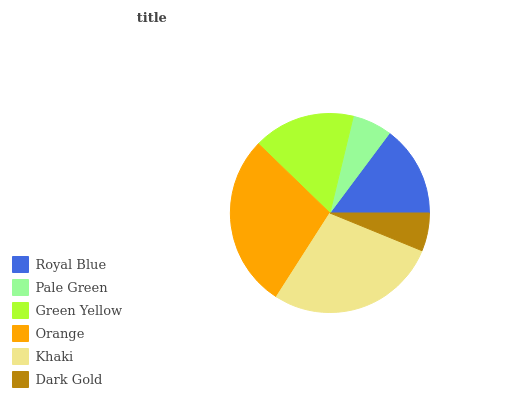Is Dark Gold the minimum?
Answer yes or no. Yes. Is Orange the maximum?
Answer yes or no. Yes. Is Pale Green the minimum?
Answer yes or no. No. Is Pale Green the maximum?
Answer yes or no. No. Is Royal Blue greater than Pale Green?
Answer yes or no. Yes. Is Pale Green less than Royal Blue?
Answer yes or no. Yes. Is Pale Green greater than Royal Blue?
Answer yes or no. No. Is Royal Blue less than Pale Green?
Answer yes or no. No. Is Green Yellow the high median?
Answer yes or no. Yes. Is Royal Blue the low median?
Answer yes or no. Yes. Is Orange the high median?
Answer yes or no. No. Is Green Yellow the low median?
Answer yes or no. No. 